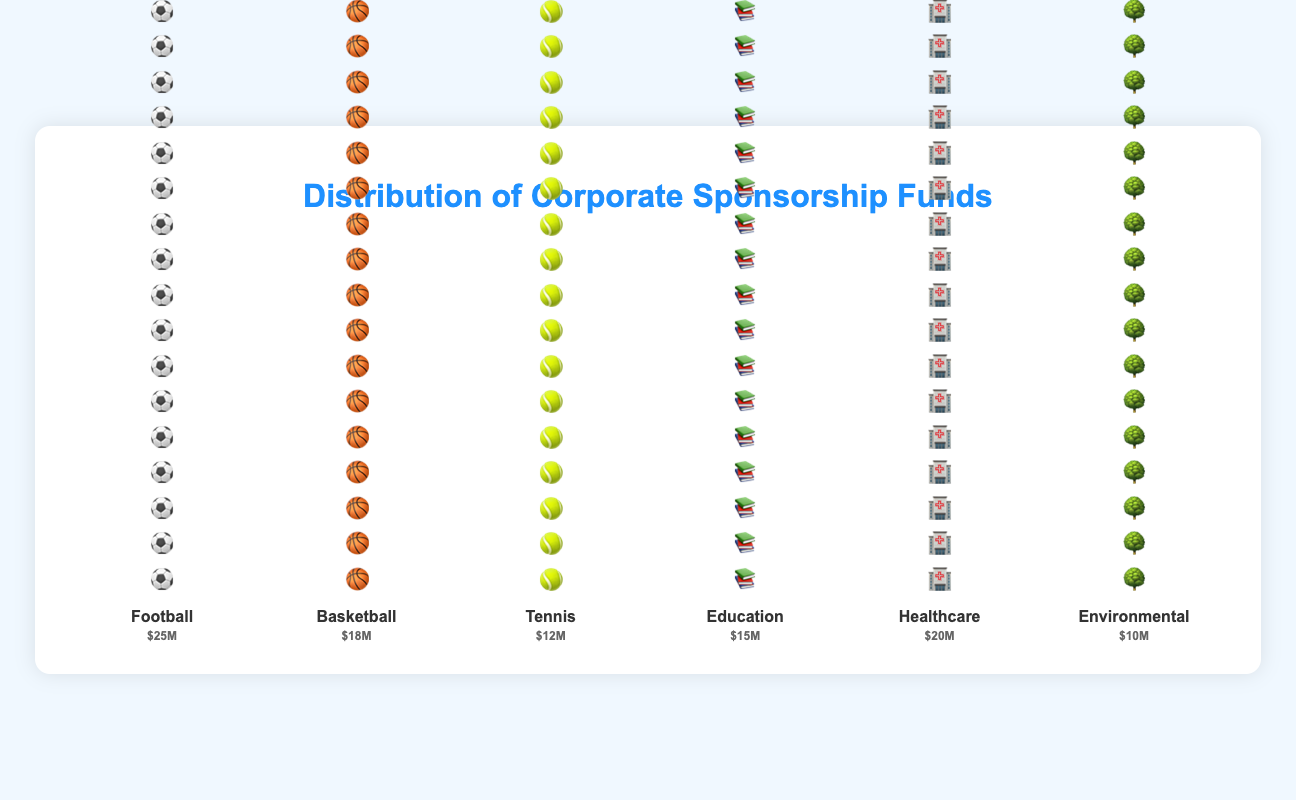What is the total amount of corporate sponsorship funds allocated to sports? The categories classified as sports in the figure are Football, Basketball, and Tennis. Summing their respective amounts gives: $25M (Football) + $18M (Basketball) + $12M (Tennis) = $55M
Answer: $55M Which category has the highest amount of corporate sponsorship funds? By visually comparing the heights of the icons, Football stands out as the tallest, which means it has the highest amount of corporate sponsorship funds at $25M
Answer: Football How much more funding does Football receive than Basketball? Football receives $25M while Basketball receives $18M. The difference is calculated as $25M - $18M = $7M
Answer: $7M What is the total amount of corporate sponsorship funds allocated to social initiatives? The categories classified as social initiatives are Education, Healthcare, and Environmental. Summing their respective amounts gives: $15M (Education) + $20M (Healthcare) + $10M (Environmental) = $45M
Answer: $45M How does the funding for Environmental initiatives compare to Tennis? Environmental initiatives receive $10M while Tennis receives $12M. By comparing the two, Tennis receives $2M more than Environmental initiatives
Answer: Tennis Which social initiative receives the least amount of funding? Visually inspecting the category bars for social initiatives, Environmental is the shortest, indicating it receives the least amount at $10M
Answer: Environmental What is the percentage of total funds allocated to Healthcare out of the total sponsorship? First, calculate the total sponsorship funds: $25M (Football) + $18M (Basketball) + $12M (Tennis) + $15M (Education) + $20M (Healthcare) + $10M (Environmental) = $100M. The percentage for Healthcare is then ($20M / $100M) * 100 = 20%
Answer: 20% How does the average funding for sports categories compare to social initiative categories? Calculating the average for sports: ($25M + $18M + $12M) / 3 = $55M / 3 ≈ $18.33M. Calculating the average for social initiatives: ($15M + $20M + $10M) / 3 ≈ $45M / 3 ≈ $15M. Therefore, the average funding for sports is higher ($18.33M) compared to social initiatives ($15M)
Answer: $18.33M vs $15M Which category receives the second highest amount of corporate sponsorship funds? In the figure, Healthcare is the second tallest after Football, which means Healthcare receives the second highest amount of funds at $20M
Answer: Healthcare 